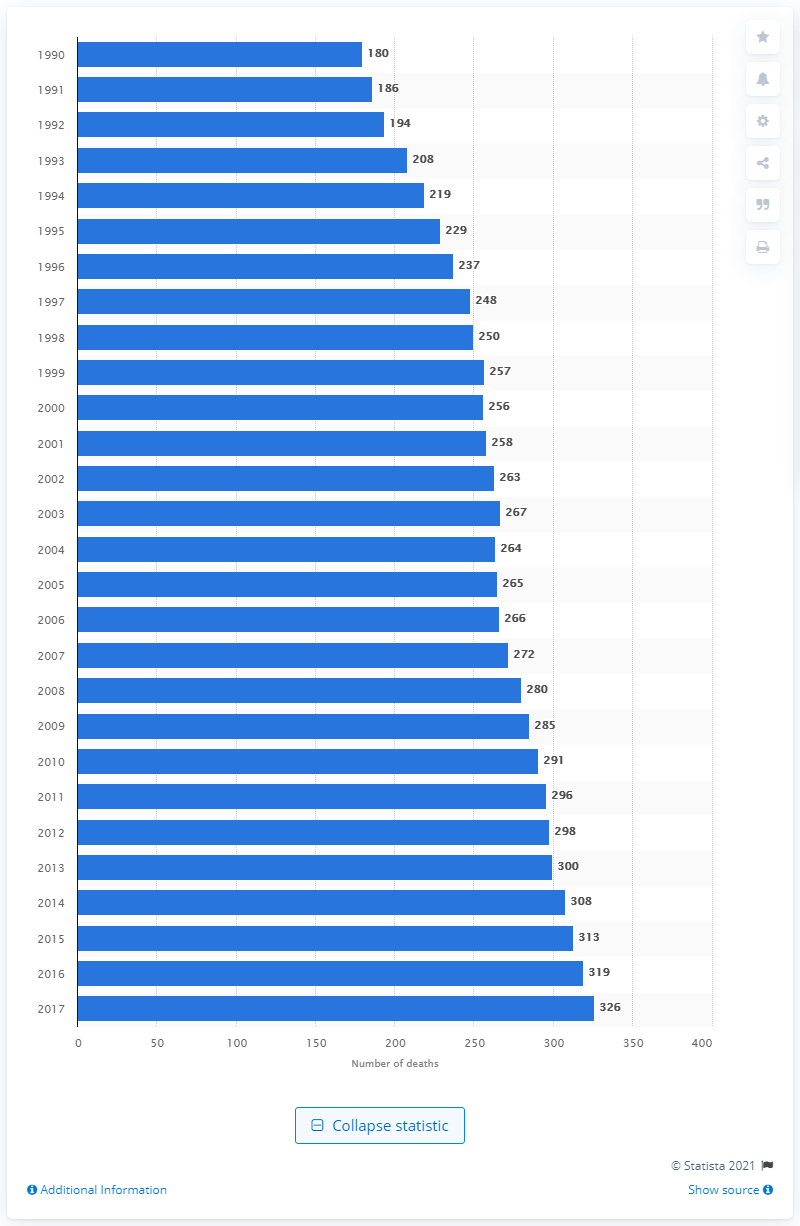Identify some key points in this picture. The yearly number of deaths from eating disorders from 1990 to 2017 was 326. In 1990, the yearly number of deaths from eating disorders was 180. 